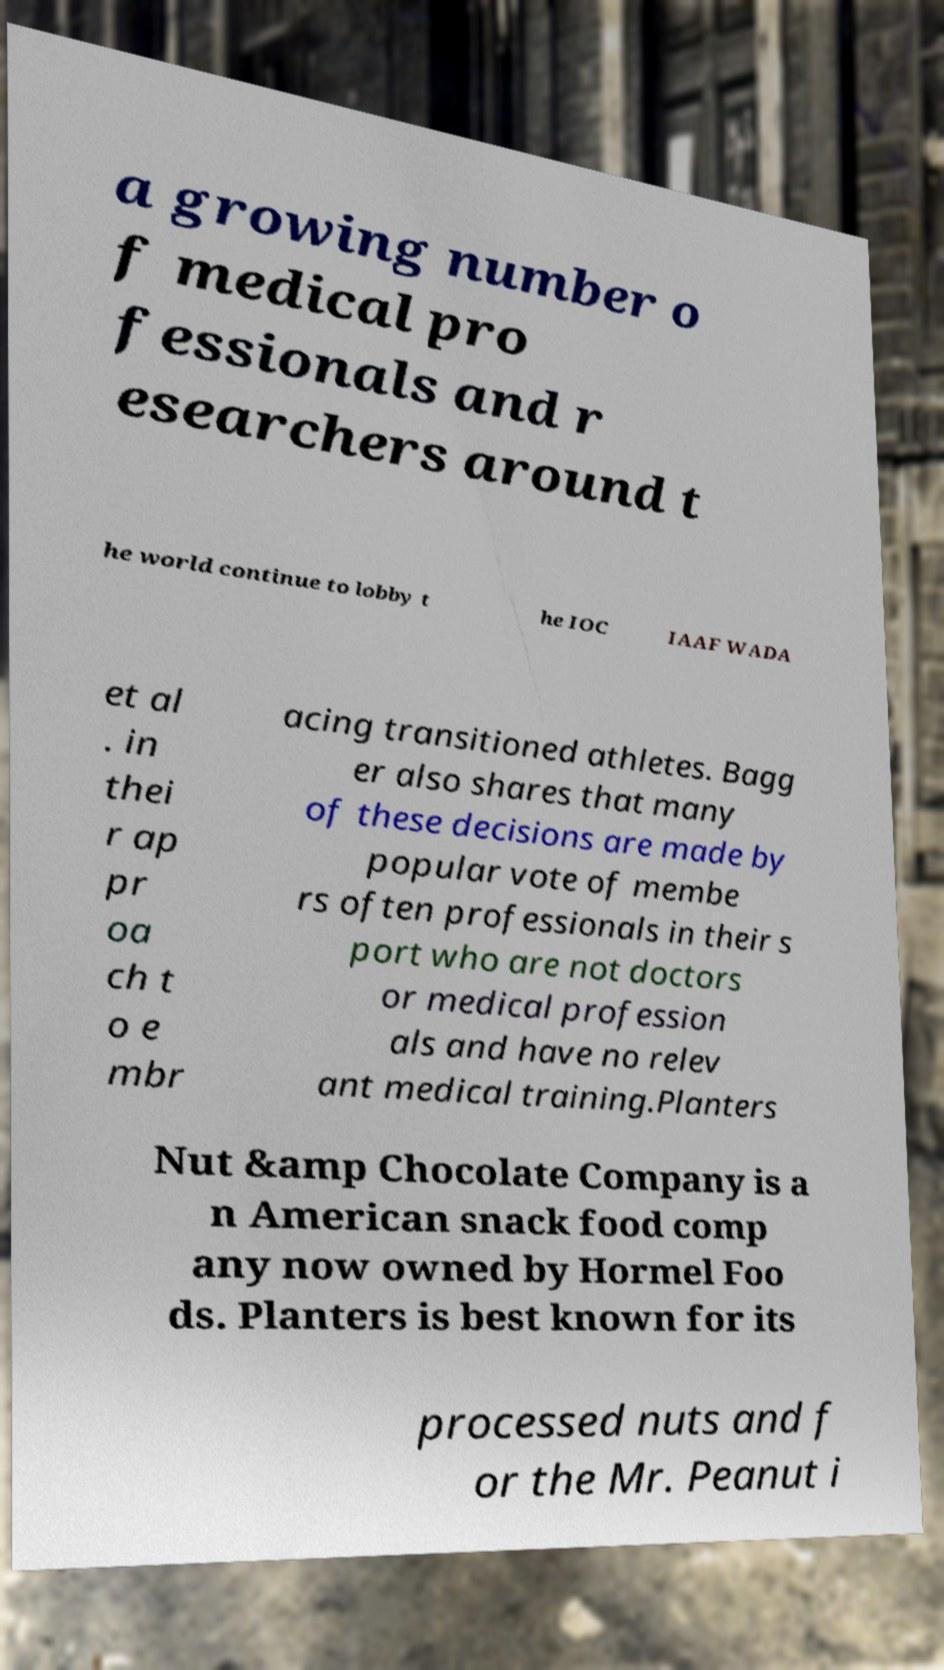Please identify and transcribe the text found in this image. a growing number o f medical pro fessionals and r esearchers around t he world continue to lobby t he IOC IAAF WADA et al . in thei r ap pr oa ch t o e mbr acing transitioned athletes. Bagg er also shares that many of these decisions are made by popular vote of membe rs often professionals in their s port who are not doctors or medical profession als and have no relev ant medical training.Planters Nut &amp Chocolate Company is a n American snack food comp any now owned by Hormel Foo ds. Planters is best known for its processed nuts and f or the Mr. Peanut i 